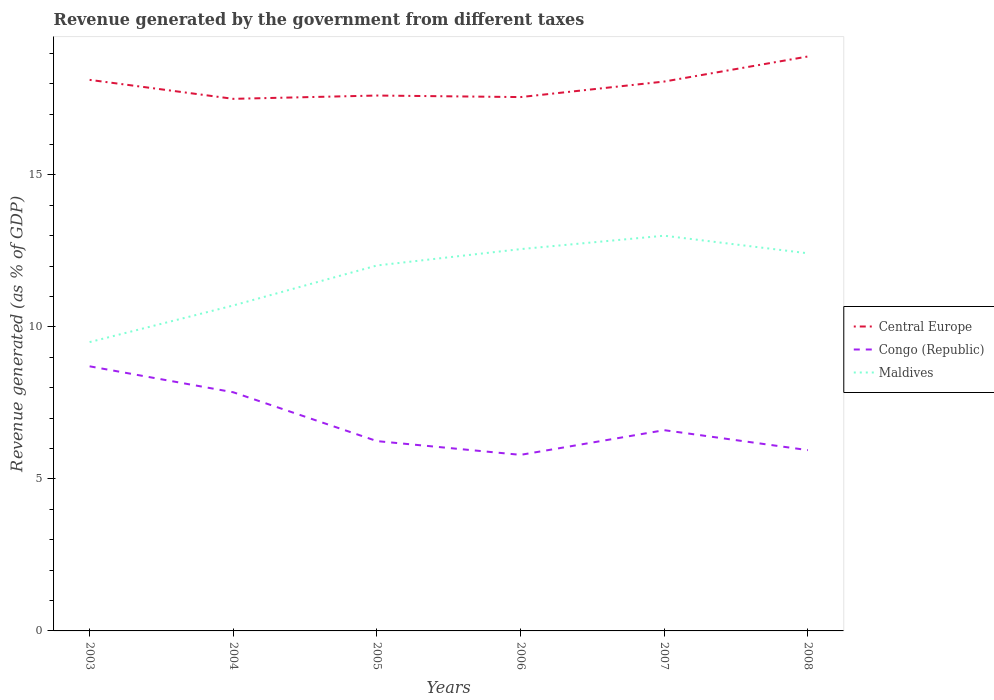How many different coloured lines are there?
Keep it short and to the point. 3. Is the number of lines equal to the number of legend labels?
Your answer should be compact. Yes. Across all years, what is the maximum revenue generated by the government in Congo (Republic)?
Provide a short and direct response. 5.79. What is the total revenue generated by the government in Maldives in the graph?
Your response must be concise. -1.32. What is the difference between the highest and the second highest revenue generated by the government in Maldives?
Your response must be concise. 3.5. Are the values on the major ticks of Y-axis written in scientific E-notation?
Your response must be concise. No. Does the graph contain grids?
Ensure brevity in your answer.  No. Where does the legend appear in the graph?
Your answer should be compact. Center right. What is the title of the graph?
Keep it short and to the point. Revenue generated by the government from different taxes. What is the label or title of the X-axis?
Give a very brief answer. Years. What is the label or title of the Y-axis?
Your answer should be very brief. Revenue generated (as % of GDP). What is the Revenue generated (as % of GDP) in Central Europe in 2003?
Give a very brief answer. 18.12. What is the Revenue generated (as % of GDP) in Congo (Republic) in 2003?
Your answer should be compact. 8.7. What is the Revenue generated (as % of GDP) of Maldives in 2003?
Ensure brevity in your answer.  9.5. What is the Revenue generated (as % of GDP) in Central Europe in 2004?
Provide a short and direct response. 17.5. What is the Revenue generated (as % of GDP) in Congo (Republic) in 2004?
Offer a very short reply. 7.85. What is the Revenue generated (as % of GDP) in Maldives in 2004?
Give a very brief answer. 10.7. What is the Revenue generated (as % of GDP) of Central Europe in 2005?
Give a very brief answer. 17.61. What is the Revenue generated (as % of GDP) in Congo (Republic) in 2005?
Give a very brief answer. 6.24. What is the Revenue generated (as % of GDP) of Maldives in 2005?
Your answer should be very brief. 12.02. What is the Revenue generated (as % of GDP) in Central Europe in 2006?
Ensure brevity in your answer.  17.56. What is the Revenue generated (as % of GDP) of Congo (Republic) in 2006?
Your answer should be compact. 5.79. What is the Revenue generated (as % of GDP) of Maldives in 2006?
Give a very brief answer. 12.56. What is the Revenue generated (as % of GDP) in Central Europe in 2007?
Ensure brevity in your answer.  18.07. What is the Revenue generated (as % of GDP) of Congo (Republic) in 2007?
Make the answer very short. 6.6. What is the Revenue generated (as % of GDP) in Maldives in 2007?
Provide a short and direct response. 13. What is the Revenue generated (as % of GDP) in Central Europe in 2008?
Your response must be concise. 18.89. What is the Revenue generated (as % of GDP) of Congo (Republic) in 2008?
Your answer should be very brief. 5.95. What is the Revenue generated (as % of GDP) of Maldives in 2008?
Ensure brevity in your answer.  12.42. Across all years, what is the maximum Revenue generated (as % of GDP) of Central Europe?
Your response must be concise. 18.89. Across all years, what is the maximum Revenue generated (as % of GDP) in Congo (Republic)?
Your answer should be compact. 8.7. Across all years, what is the maximum Revenue generated (as % of GDP) in Maldives?
Give a very brief answer. 13. Across all years, what is the minimum Revenue generated (as % of GDP) in Central Europe?
Your response must be concise. 17.5. Across all years, what is the minimum Revenue generated (as % of GDP) of Congo (Republic)?
Your answer should be very brief. 5.79. Across all years, what is the minimum Revenue generated (as % of GDP) in Maldives?
Provide a short and direct response. 9.5. What is the total Revenue generated (as % of GDP) in Central Europe in the graph?
Offer a terse response. 107.75. What is the total Revenue generated (as % of GDP) of Congo (Republic) in the graph?
Offer a very short reply. 41.13. What is the total Revenue generated (as % of GDP) of Maldives in the graph?
Provide a short and direct response. 70.2. What is the difference between the Revenue generated (as % of GDP) of Central Europe in 2003 and that in 2004?
Your answer should be compact. 0.62. What is the difference between the Revenue generated (as % of GDP) in Congo (Republic) in 2003 and that in 2004?
Keep it short and to the point. 0.85. What is the difference between the Revenue generated (as % of GDP) of Maldives in 2003 and that in 2004?
Offer a terse response. -1.2. What is the difference between the Revenue generated (as % of GDP) of Central Europe in 2003 and that in 2005?
Make the answer very short. 0.52. What is the difference between the Revenue generated (as % of GDP) of Congo (Republic) in 2003 and that in 2005?
Offer a very short reply. 2.46. What is the difference between the Revenue generated (as % of GDP) of Maldives in 2003 and that in 2005?
Offer a terse response. -2.52. What is the difference between the Revenue generated (as % of GDP) of Central Europe in 2003 and that in 2006?
Make the answer very short. 0.57. What is the difference between the Revenue generated (as % of GDP) of Congo (Republic) in 2003 and that in 2006?
Your response must be concise. 2.91. What is the difference between the Revenue generated (as % of GDP) of Maldives in 2003 and that in 2006?
Offer a very short reply. -3.06. What is the difference between the Revenue generated (as % of GDP) in Central Europe in 2003 and that in 2007?
Offer a very short reply. 0.06. What is the difference between the Revenue generated (as % of GDP) of Congo (Republic) in 2003 and that in 2007?
Keep it short and to the point. 2.1. What is the difference between the Revenue generated (as % of GDP) in Maldives in 2003 and that in 2007?
Offer a terse response. -3.5. What is the difference between the Revenue generated (as % of GDP) of Central Europe in 2003 and that in 2008?
Ensure brevity in your answer.  -0.77. What is the difference between the Revenue generated (as % of GDP) in Congo (Republic) in 2003 and that in 2008?
Provide a short and direct response. 2.76. What is the difference between the Revenue generated (as % of GDP) in Maldives in 2003 and that in 2008?
Ensure brevity in your answer.  -2.92. What is the difference between the Revenue generated (as % of GDP) of Central Europe in 2004 and that in 2005?
Offer a terse response. -0.11. What is the difference between the Revenue generated (as % of GDP) of Congo (Republic) in 2004 and that in 2005?
Make the answer very short. 1.61. What is the difference between the Revenue generated (as % of GDP) of Maldives in 2004 and that in 2005?
Ensure brevity in your answer.  -1.32. What is the difference between the Revenue generated (as % of GDP) in Central Europe in 2004 and that in 2006?
Your answer should be very brief. -0.06. What is the difference between the Revenue generated (as % of GDP) of Congo (Republic) in 2004 and that in 2006?
Give a very brief answer. 2.06. What is the difference between the Revenue generated (as % of GDP) of Maldives in 2004 and that in 2006?
Provide a short and direct response. -1.85. What is the difference between the Revenue generated (as % of GDP) of Central Europe in 2004 and that in 2007?
Make the answer very short. -0.57. What is the difference between the Revenue generated (as % of GDP) in Congo (Republic) in 2004 and that in 2007?
Your answer should be compact. 1.25. What is the difference between the Revenue generated (as % of GDP) in Maldives in 2004 and that in 2007?
Keep it short and to the point. -2.29. What is the difference between the Revenue generated (as % of GDP) of Central Europe in 2004 and that in 2008?
Ensure brevity in your answer.  -1.39. What is the difference between the Revenue generated (as % of GDP) in Congo (Republic) in 2004 and that in 2008?
Ensure brevity in your answer.  1.9. What is the difference between the Revenue generated (as % of GDP) of Maldives in 2004 and that in 2008?
Give a very brief answer. -1.72. What is the difference between the Revenue generated (as % of GDP) in Central Europe in 2005 and that in 2006?
Make the answer very short. 0.05. What is the difference between the Revenue generated (as % of GDP) in Congo (Republic) in 2005 and that in 2006?
Provide a short and direct response. 0.45. What is the difference between the Revenue generated (as % of GDP) of Maldives in 2005 and that in 2006?
Ensure brevity in your answer.  -0.54. What is the difference between the Revenue generated (as % of GDP) in Central Europe in 2005 and that in 2007?
Keep it short and to the point. -0.46. What is the difference between the Revenue generated (as % of GDP) in Congo (Republic) in 2005 and that in 2007?
Keep it short and to the point. -0.36. What is the difference between the Revenue generated (as % of GDP) of Maldives in 2005 and that in 2007?
Your answer should be compact. -0.98. What is the difference between the Revenue generated (as % of GDP) of Central Europe in 2005 and that in 2008?
Provide a short and direct response. -1.28. What is the difference between the Revenue generated (as % of GDP) in Congo (Republic) in 2005 and that in 2008?
Provide a short and direct response. 0.3. What is the difference between the Revenue generated (as % of GDP) of Maldives in 2005 and that in 2008?
Offer a very short reply. -0.4. What is the difference between the Revenue generated (as % of GDP) of Central Europe in 2006 and that in 2007?
Your response must be concise. -0.51. What is the difference between the Revenue generated (as % of GDP) in Congo (Republic) in 2006 and that in 2007?
Provide a succinct answer. -0.81. What is the difference between the Revenue generated (as % of GDP) of Maldives in 2006 and that in 2007?
Keep it short and to the point. -0.44. What is the difference between the Revenue generated (as % of GDP) of Central Europe in 2006 and that in 2008?
Give a very brief answer. -1.33. What is the difference between the Revenue generated (as % of GDP) in Congo (Republic) in 2006 and that in 2008?
Keep it short and to the point. -0.16. What is the difference between the Revenue generated (as % of GDP) of Maldives in 2006 and that in 2008?
Ensure brevity in your answer.  0.14. What is the difference between the Revenue generated (as % of GDP) in Central Europe in 2007 and that in 2008?
Make the answer very short. -0.82. What is the difference between the Revenue generated (as % of GDP) of Congo (Republic) in 2007 and that in 2008?
Provide a short and direct response. 0.66. What is the difference between the Revenue generated (as % of GDP) of Maldives in 2007 and that in 2008?
Your answer should be compact. 0.58. What is the difference between the Revenue generated (as % of GDP) in Central Europe in 2003 and the Revenue generated (as % of GDP) in Congo (Republic) in 2004?
Your answer should be very brief. 10.28. What is the difference between the Revenue generated (as % of GDP) in Central Europe in 2003 and the Revenue generated (as % of GDP) in Maldives in 2004?
Ensure brevity in your answer.  7.42. What is the difference between the Revenue generated (as % of GDP) of Congo (Republic) in 2003 and the Revenue generated (as % of GDP) of Maldives in 2004?
Your response must be concise. -2. What is the difference between the Revenue generated (as % of GDP) in Central Europe in 2003 and the Revenue generated (as % of GDP) in Congo (Republic) in 2005?
Offer a very short reply. 11.88. What is the difference between the Revenue generated (as % of GDP) in Central Europe in 2003 and the Revenue generated (as % of GDP) in Maldives in 2005?
Give a very brief answer. 6.1. What is the difference between the Revenue generated (as % of GDP) in Congo (Republic) in 2003 and the Revenue generated (as % of GDP) in Maldives in 2005?
Your answer should be very brief. -3.32. What is the difference between the Revenue generated (as % of GDP) in Central Europe in 2003 and the Revenue generated (as % of GDP) in Congo (Republic) in 2006?
Provide a succinct answer. 12.33. What is the difference between the Revenue generated (as % of GDP) in Central Europe in 2003 and the Revenue generated (as % of GDP) in Maldives in 2006?
Give a very brief answer. 5.57. What is the difference between the Revenue generated (as % of GDP) in Congo (Republic) in 2003 and the Revenue generated (as % of GDP) in Maldives in 2006?
Provide a succinct answer. -3.85. What is the difference between the Revenue generated (as % of GDP) of Central Europe in 2003 and the Revenue generated (as % of GDP) of Congo (Republic) in 2007?
Your response must be concise. 11.52. What is the difference between the Revenue generated (as % of GDP) in Central Europe in 2003 and the Revenue generated (as % of GDP) in Maldives in 2007?
Your answer should be compact. 5.13. What is the difference between the Revenue generated (as % of GDP) of Congo (Republic) in 2003 and the Revenue generated (as % of GDP) of Maldives in 2007?
Make the answer very short. -4.3. What is the difference between the Revenue generated (as % of GDP) in Central Europe in 2003 and the Revenue generated (as % of GDP) in Congo (Republic) in 2008?
Make the answer very short. 12.18. What is the difference between the Revenue generated (as % of GDP) in Central Europe in 2003 and the Revenue generated (as % of GDP) in Maldives in 2008?
Make the answer very short. 5.7. What is the difference between the Revenue generated (as % of GDP) of Congo (Republic) in 2003 and the Revenue generated (as % of GDP) of Maldives in 2008?
Make the answer very short. -3.72. What is the difference between the Revenue generated (as % of GDP) of Central Europe in 2004 and the Revenue generated (as % of GDP) of Congo (Republic) in 2005?
Provide a short and direct response. 11.26. What is the difference between the Revenue generated (as % of GDP) of Central Europe in 2004 and the Revenue generated (as % of GDP) of Maldives in 2005?
Offer a terse response. 5.48. What is the difference between the Revenue generated (as % of GDP) in Congo (Republic) in 2004 and the Revenue generated (as % of GDP) in Maldives in 2005?
Ensure brevity in your answer.  -4.17. What is the difference between the Revenue generated (as % of GDP) of Central Europe in 2004 and the Revenue generated (as % of GDP) of Congo (Republic) in 2006?
Your answer should be compact. 11.71. What is the difference between the Revenue generated (as % of GDP) of Central Europe in 2004 and the Revenue generated (as % of GDP) of Maldives in 2006?
Offer a terse response. 4.94. What is the difference between the Revenue generated (as % of GDP) of Congo (Republic) in 2004 and the Revenue generated (as % of GDP) of Maldives in 2006?
Ensure brevity in your answer.  -4.71. What is the difference between the Revenue generated (as % of GDP) of Central Europe in 2004 and the Revenue generated (as % of GDP) of Congo (Republic) in 2007?
Ensure brevity in your answer.  10.9. What is the difference between the Revenue generated (as % of GDP) in Central Europe in 2004 and the Revenue generated (as % of GDP) in Maldives in 2007?
Offer a very short reply. 4.5. What is the difference between the Revenue generated (as % of GDP) of Congo (Republic) in 2004 and the Revenue generated (as % of GDP) of Maldives in 2007?
Your answer should be very brief. -5.15. What is the difference between the Revenue generated (as % of GDP) in Central Europe in 2004 and the Revenue generated (as % of GDP) in Congo (Republic) in 2008?
Provide a short and direct response. 11.55. What is the difference between the Revenue generated (as % of GDP) in Central Europe in 2004 and the Revenue generated (as % of GDP) in Maldives in 2008?
Your response must be concise. 5.08. What is the difference between the Revenue generated (as % of GDP) of Congo (Republic) in 2004 and the Revenue generated (as % of GDP) of Maldives in 2008?
Provide a short and direct response. -4.57. What is the difference between the Revenue generated (as % of GDP) of Central Europe in 2005 and the Revenue generated (as % of GDP) of Congo (Republic) in 2006?
Provide a succinct answer. 11.82. What is the difference between the Revenue generated (as % of GDP) in Central Europe in 2005 and the Revenue generated (as % of GDP) in Maldives in 2006?
Your response must be concise. 5.05. What is the difference between the Revenue generated (as % of GDP) in Congo (Republic) in 2005 and the Revenue generated (as % of GDP) in Maldives in 2006?
Offer a terse response. -6.31. What is the difference between the Revenue generated (as % of GDP) in Central Europe in 2005 and the Revenue generated (as % of GDP) in Congo (Republic) in 2007?
Ensure brevity in your answer.  11.01. What is the difference between the Revenue generated (as % of GDP) of Central Europe in 2005 and the Revenue generated (as % of GDP) of Maldives in 2007?
Your response must be concise. 4.61. What is the difference between the Revenue generated (as % of GDP) in Congo (Republic) in 2005 and the Revenue generated (as % of GDP) in Maldives in 2007?
Provide a succinct answer. -6.76. What is the difference between the Revenue generated (as % of GDP) of Central Europe in 2005 and the Revenue generated (as % of GDP) of Congo (Republic) in 2008?
Offer a very short reply. 11.66. What is the difference between the Revenue generated (as % of GDP) of Central Europe in 2005 and the Revenue generated (as % of GDP) of Maldives in 2008?
Your response must be concise. 5.19. What is the difference between the Revenue generated (as % of GDP) in Congo (Republic) in 2005 and the Revenue generated (as % of GDP) in Maldives in 2008?
Offer a very short reply. -6.18. What is the difference between the Revenue generated (as % of GDP) in Central Europe in 2006 and the Revenue generated (as % of GDP) in Congo (Republic) in 2007?
Your answer should be compact. 10.96. What is the difference between the Revenue generated (as % of GDP) in Central Europe in 2006 and the Revenue generated (as % of GDP) in Maldives in 2007?
Your answer should be compact. 4.56. What is the difference between the Revenue generated (as % of GDP) of Congo (Republic) in 2006 and the Revenue generated (as % of GDP) of Maldives in 2007?
Your answer should be compact. -7.21. What is the difference between the Revenue generated (as % of GDP) in Central Europe in 2006 and the Revenue generated (as % of GDP) in Congo (Republic) in 2008?
Provide a short and direct response. 11.61. What is the difference between the Revenue generated (as % of GDP) in Central Europe in 2006 and the Revenue generated (as % of GDP) in Maldives in 2008?
Offer a very short reply. 5.14. What is the difference between the Revenue generated (as % of GDP) of Congo (Republic) in 2006 and the Revenue generated (as % of GDP) of Maldives in 2008?
Provide a short and direct response. -6.63. What is the difference between the Revenue generated (as % of GDP) in Central Europe in 2007 and the Revenue generated (as % of GDP) in Congo (Republic) in 2008?
Make the answer very short. 12.12. What is the difference between the Revenue generated (as % of GDP) in Central Europe in 2007 and the Revenue generated (as % of GDP) in Maldives in 2008?
Your response must be concise. 5.65. What is the difference between the Revenue generated (as % of GDP) of Congo (Republic) in 2007 and the Revenue generated (as % of GDP) of Maldives in 2008?
Ensure brevity in your answer.  -5.82. What is the average Revenue generated (as % of GDP) in Central Europe per year?
Your answer should be very brief. 17.96. What is the average Revenue generated (as % of GDP) in Congo (Republic) per year?
Your answer should be compact. 6.86. What is the average Revenue generated (as % of GDP) of Maldives per year?
Your answer should be compact. 11.7. In the year 2003, what is the difference between the Revenue generated (as % of GDP) in Central Europe and Revenue generated (as % of GDP) in Congo (Republic)?
Give a very brief answer. 9.42. In the year 2003, what is the difference between the Revenue generated (as % of GDP) in Central Europe and Revenue generated (as % of GDP) in Maldives?
Offer a very short reply. 8.62. In the year 2003, what is the difference between the Revenue generated (as % of GDP) of Congo (Republic) and Revenue generated (as % of GDP) of Maldives?
Your answer should be very brief. -0.8. In the year 2004, what is the difference between the Revenue generated (as % of GDP) of Central Europe and Revenue generated (as % of GDP) of Congo (Republic)?
Give a very brief answer. 9.65. In the year 2004, what is the difference between the Revenue generated (as % of GDP) of Central Europe and Revenue generated (as % of GDP) of Maldives?
Ensure brevity in your answer.  6.8. In the year 2004, what is the difference between the Revenue generated (as % of GDP) in Congo (Republic) and Revenue generated (as % of GDP) in Maldives?
Provide a short and direct response. -2.85. In the year 2005, what is the difference between the Revenue generated (as % of GDP) of Central Europe and Revenue generated (as % of GDP) of Congo (Republic)?
Provide a succinct answer. 11.37. In the year 2005, what is the difference between the Revenue generated (as % of GDP) in Central Europe and Revenue generated (as % of GDP) in Maldives?
Give a very brief answer. 5.59. In the year 2005, what is the difference between the Revenue generated (as % of GDP) in Congo (Republic) and Revenue generated (as % of GDP) in Maldives?
Offer a very short reply. -5.78. In the year 2006, what is the difference between the Revenue generated (as % of GDP) of Central Europe and Revenue generated (as % of GDP) of Congo (Republic)?
Provide a succinct answer. 11.77. In the year 2006, what is the difference between the Revenue generated (as % of GDP) in Central Europe and Revenue generated (as % of GDP) in Maldives?
Keep it short and to the point. 5. In the year 2006, what is the difference between the Revenue generated (as % of GDP) in Congo (Republic) and Revenue generated (as % of GDP) in Maldives?
Keep it short and to the point. -6.77. In the year 2007, what is the difference between the Revenue generated (as % of GDP) in Central Europe and Revenue generated (as % of GDP) in Congo (Republic)?
Offer a terse response. 11.47. In the year 2007, what is the difference between the Revenue generated (as % of GDP) of Central Europe and Revenue generated (as % of GDP) of Maldives?
Your answer should be very brief. 5.07. In the year 2007, what is the difference between the Revenue generated (as % of GDP) in Congo (Republic) and Revenue generated (as % of GDP) in Maldives?
Make the answer very short. -6.4. In the year 2008, what is the difference between the Revenue generated (as % of GDP) in Central Europe and Revenue generated (as % of GDP) in Congo (Republic)?
Your response must be concise. 12.95. In the year 2008, what is the difference between the Revenue generated (as % of GDP) in Central Europe and Revenue generated (as % of GDP) in Maldives?
Your response must be concise. 6.47. In the year 2008, what is the difference between the Revenue generated (as % of GDP) of Congo (Republic) and Revenue generated (as % of GDP) of Maldives?
Your answer should be compact. -6.47. What is the ratio of the Revenue generated (as % of GDP) of Central Europe in 2003 to that in 2004?
Your answer should be compact. 1.04. What is the ratio of the Revenue generated (as % of GDP) in Congo (Republic) in 2003 to that in 2004?
Keep it short and to the point. 1.11. What is the ratio of the Revenue generated (as % of GDP) in Maldives in 2003 to that in 2004?
Give a very brief answer. 0.89. What is the ratio of the Revenue generated (as % of GDP) of Central Europe in 2003 to that in 2005?
Your answer should be compact. 1.03. What is the ratio of the Revenue generated (as % of GDP) of Congo (Republic) in 2003 to that in 2005?
Your response must be concise. 1.39. What is the ratio of the Revenue generated (as % of GDP) in Maldives in 2003 to that in 2005?
Give a very brief answer. 0.79. What is the ratio of the Revenue generated (as % of GDP) of Central Europe in 2003 to that in 2006?
Offer a very short reply. 1.03. What is the ratio of the Revenue generated (as % of GDP) of Congo (Republic) in 2003 to that in 2006?
Make the answer very short. 1.5. What is the ratio of the Revenue generated (as % of GDP) of Maldives in 2003 to that in 2006?
Your response must be concise. 0.76. What is the ratio of the Revenue generated (as % of GDP) of Central Europe in 2003 to that in 2007?
Make the answer very short. 1. What is the ratio of the Revenue generated (as % of GDP) of Congo (Republic) in 2003 to that in 2007?
Offer a terse response. 1.32. What is the ratio of the Revenue generated (as % of GDP) of Maldives in 2003 to that in 2007?
Your answer should be very brief. 0.73. What is the ratio of the Revenue generated (as % of GDP) of Central Europe in 2003 to that in 2008?
Keep it short and to the point. 0.96. What is the ratio of the Revenue generated (as % of GDP) of Congo (Republic) in 2003 to that in 2008?
Make the answer very short. 1.46. What is the ratio of the Revenue generated (as % of GDP) of Maldives in 2003 to that in 2008?
Offer a terse response. 0.76. What is the ratio of the Revenue generated (as % of GDP) in Congo (Republic) in 2004 to that in 2005?
Your answer should be very brief. 1.26. What is the ratio of the Revenue generated (as % of GDP) of Maldives in 2004 to that in 2005?
Provide a short and direct response. 0.89. What is the ratio of the Revenue generated (as % of GDP) in Central Europe in 2004 to that in 2006?
Keep it short and to the point. 1. What is the ratio of the Revenue generated (as % of GDP) of Congo (Republic) in 2004 to that in 2006?
Give a very brief answer. 1.36. What is the ratio of the Revenue generated (as % of GDP) of Maldives in 2004 to that in 2006?
Give a very brief answer. 0.85. What is the ratio of the Revenue generated (as % of GDP) of Central Europe in 2004 to that in 2007?
Your answer should be compact. 0.97. What is the ratio of the Revenue generated (as % of GDP) in Congo (Republic) in 2004 to that in 2007?
Give a very brief answer. 1.19. What is the ratio of the Revenue generated (as % of GDP) in Maldives in 2004 to that in 2007?
Give a very brief answer. 0.82. What is the ratio of the Revenue generated (as % of GDP) in Central Europe in 2004 to that in 2008?
Give a very brief answer. 0.93. What is the ratio of the Revenue generated (as % of GDP) of Congo (Republic) in 2004 to that in 2008?
Provide a succinct answer. 1.32. What is the ratio of the Revenue generated (as % of GDP) in Maldives in 2004 to that in 2008?
Offer a terse response. 0.86. What is the ratio of the Revenue generated (as % of GDP) in Congo (Republic) in 2005 to that in 2006?
Provide a short and direct response. 1.08. What is the ratio of the Revenue generated (as % of GDP) in Maldives in 2005 to that in 2006?
Provide a succinct answer. 0.96. What is the ratio of the Revenue generated (as % of GDP) in Central Europe in 2005 to that in 2007?
Your response must be concise. 0.97. What is the ratio of the Revenue generated (as % of GDP) of Congo (Republic) in 2005 to that in 2007?
Ensure brevity in your answer.  0.95. What is the ratio of the Revenue generated (as % of GDP) of Maldives in 2005 to that in 2007?
Provide a short and direct response. 0.92. What is the ratio of the Revenue generated (as % of GDP) of Central Europe in 2005 to that in 2008?
Your answer should be compact. 0.93. What is the ratio of the Revenue generated (as % of GDP) of Congo (Republic) in 2005 to that in 2008?
Your answer should be compact. 1.05. What is the ratio of the Revenue generated (as % of GDP) in Central Europe in 2006 to that in 2007?
Provide a succinct answer. 0.97. What is the ratio of the Revenue generated (as % of GDP) in Congo (Republic) in 2006 to that in 2007?
Your answer should be compact. 0.88. What is the ratio of the Revenue generated (as % of GDP) in Maldives in 2006 to that in 2007?
Make the answer very short. 0.97. What is the ratio of the Revenue generated (as % of GDP) of Central Europe in 2006 to that in 2008?
Ensure brevity in your answer.  0.93. What is the ratio of the Revenue generated (as % of GDP) of Congo (Republic) in 2006 to that in 2008?
Give a very brief answer. 0.97. What is the ratio of the Revenue generated (as % of GDP) in Maldives in 2006 to that in 2008?
Offer a terse response. 1.01. What is the ratio of the Revenue generated (as % of GDP) of Central Europe in 2007 to that in 2008?
Your answer should be very brief. 0.96. What is the ratio of the Revenue generated (as % of GDP) in Congo (Republic) in 2007 to that in 2008?
Provide a succinct answer. 1.11. What is the ratio of the Revenue generated (as % of GDP) in Maldives in 2007 to that in 2008?
Provide a short and direct response. 1.05. What is the difference between the highest and the second highest Revenue generated (as % of GDP) of Central Europe?
Offer a terse response. 0.77. What is the difference between the highest and the second highest Revenue generated (as % of GDP) in Congo (Republic)?
Keep it short and to the point. 0.85. What is the difference between the highest and the second highest Revenue generated (as % of GDP) of Maldives?
Give a very brief answer. 0.44. What is the difference between the highest and the lowest Revenue generated (as % of GDP) in Central Europe?
Your answer should be compact. 1.39. What is the difference between the highest and the lowest Revenue generated (as % of GDP) in Congo (Republic)?
Your answer should be compact. 2.91. What is the difference between the highest and the lowest Revenue generated (as % of GDP) in Maldives?
Your response must be concise. 3.5. 